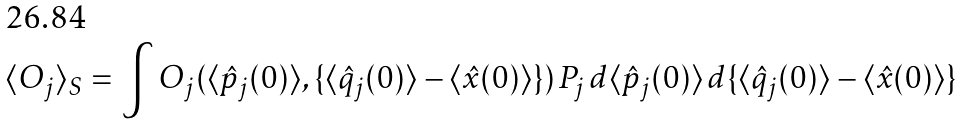Convert formula to latex. <formula><loc_0><loc_0><loc_500><loc_500>\langle O _ { j } \rangle _ { S } = \int O _ { j } ( \langle \hat { p } _ { j } ( 0 ) \rangle , \{ \langle \hat { q } _ { j } ( 0 ) \rangle - \langle \hat { x } ( 0 ) \rangle \} ) \, P _ { j } \, d \langle \hat { p } _ { j } ( 0 ) \rangle \, d \{ \langle \hat { q } _ { j } ( 0 ) \rangle - \langle \hat { x } ( 0 ) \rangle \}</formula> 